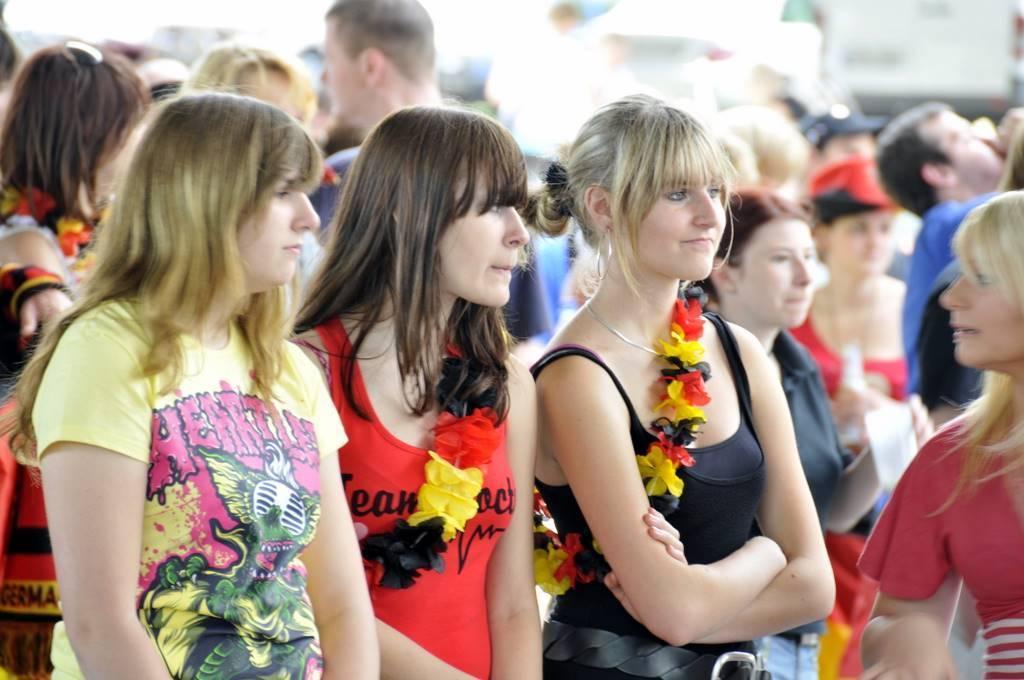Could you give a brief overview of what you see in this image? In this image I can see the group of people are standing and wearing different color dresses. Background is blurred. 